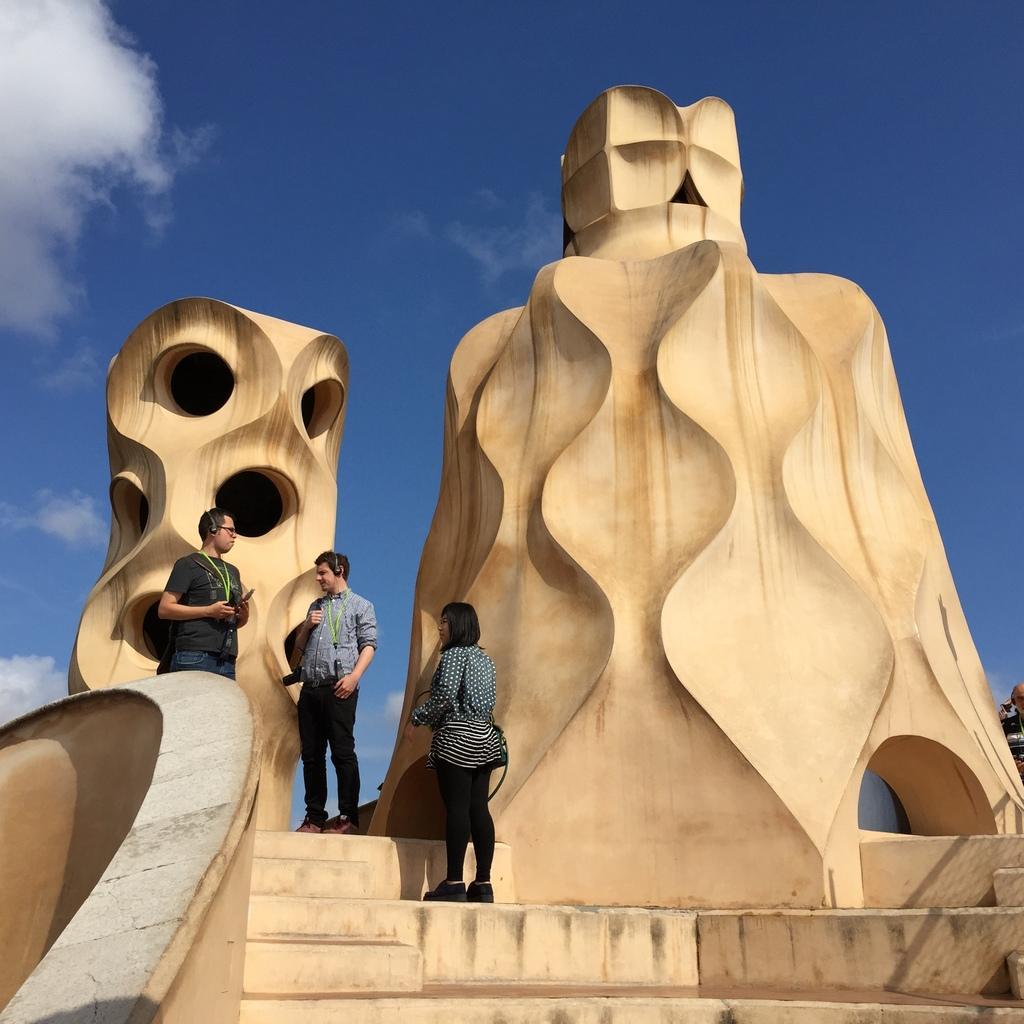In one or two sentences, can you explain what this image depicts? There are three people standing and carrying bags. We can see sculptures and steps. In the background we can see sky with clouds. On the right side of the image we can see a person. 